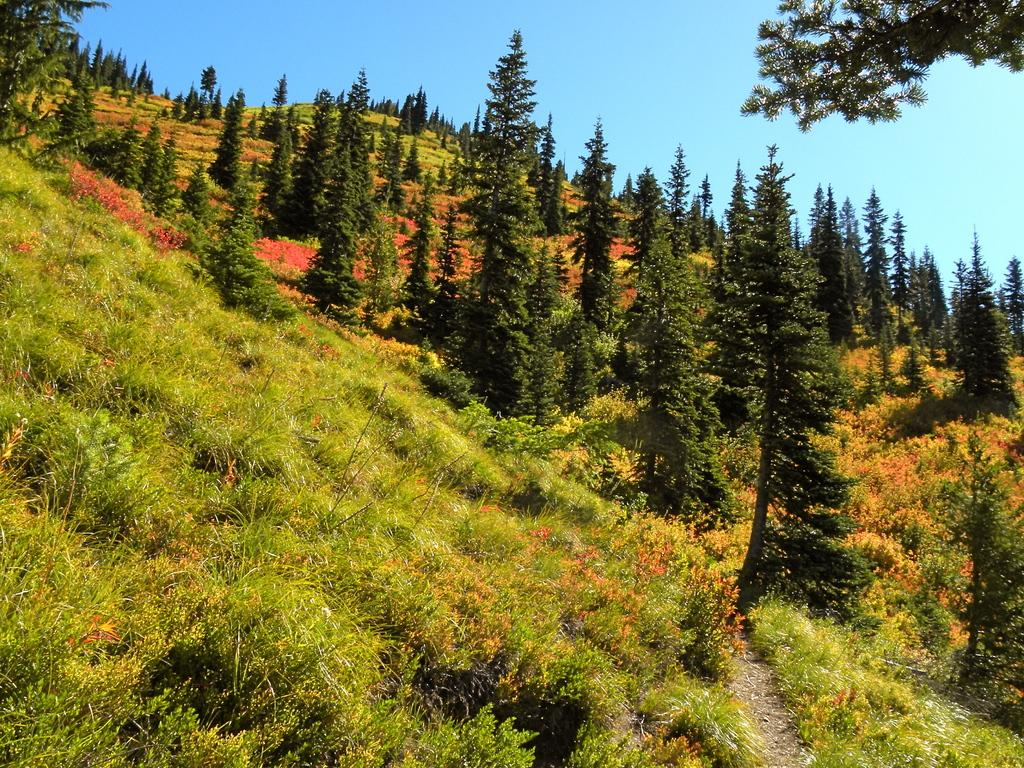What type of vegetation can be seen in the image? There is grass and trees in the image. What part of the natural environment is visible in the image? The sky is visible in the image. What type of horn can be seen in the image? There is no horn present in the image. What type of bag is visible in the image? There is no bag present in the image. 